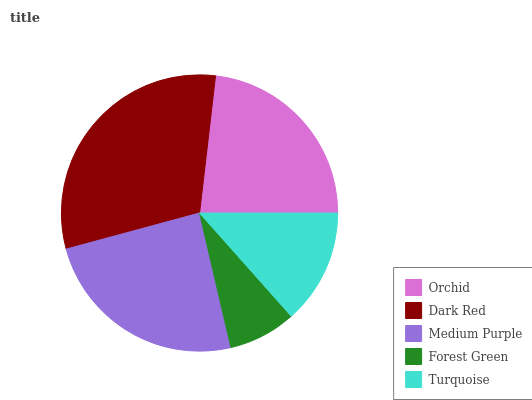Is Forest Green the minimum?
Answer yes or no. Yes. Is Dark Red the maximum?
Answer yes or no. Yes. Is Medium Purple the minimum?
Answer yes or no. No. Is Medium Purple the maximum?
Answer yes or no. No. Is Dark Red greater than Medium Purple?
Answer yes or no. Yes. Is Medium Purple less than Dark Red?
Answer yes or no. Yes. Is Medium Purple greater than Dark Red?
Answer yes or no. No. Is Dark Red less than Medium Purple?
Answer yes or no. No. Is Orchid the high median?
Answer yes or no. Yes. Is Orchid the low median?
Answer yes or no. Yes. Is Medium Purple the high median?
Answer yes or no. No. Is Dark Red the low median?
Answer yes or no. No. 